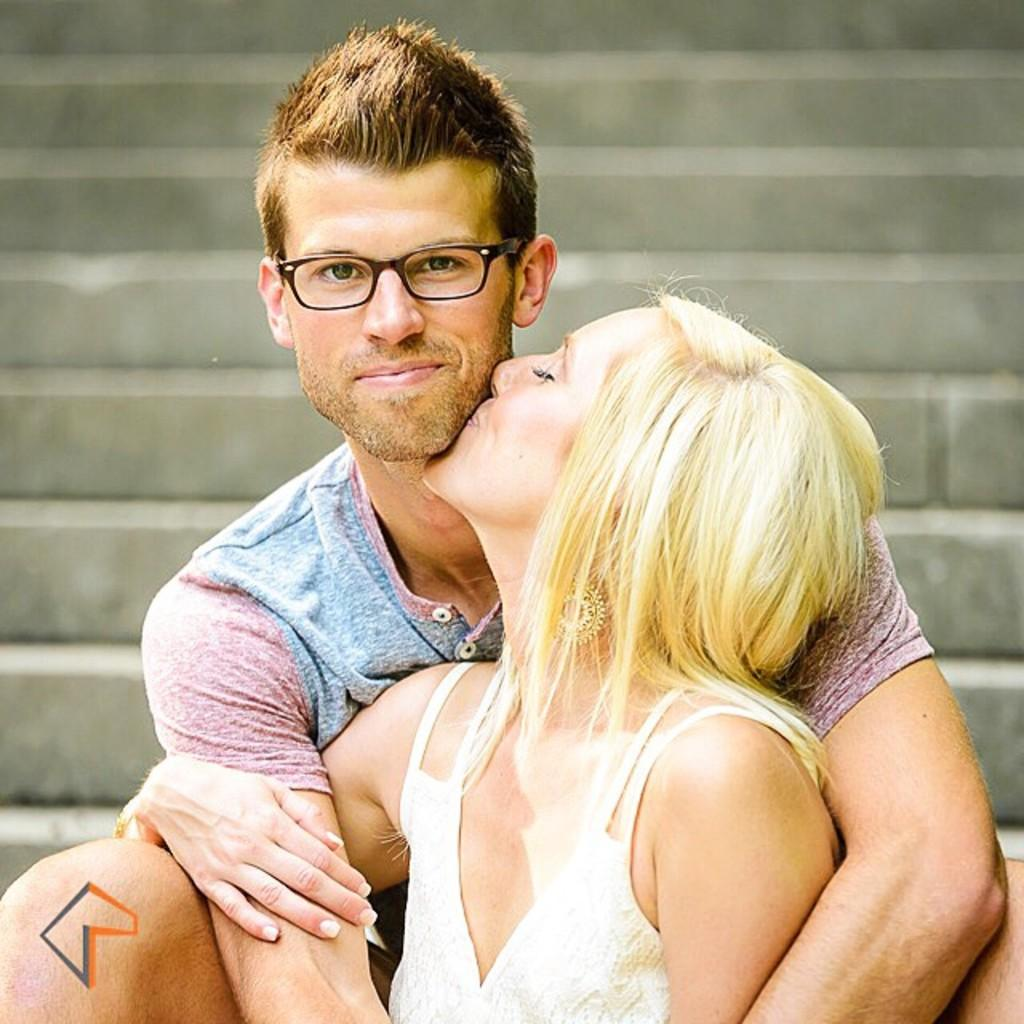Who is present in the image? There is a woman and a man in the image. What are the woman and the man doing? The woman is kissing the man, and the man is smiling. Can you describe the man's appearance? The man is wearing glasses. What can be seen in the background of the image? There are stairs visible in the background of the image. What type of steam is coming from the woman's stomach in the image? There is no steam coming from the woman's stomach in the image, as it does not depict any steam or reference to a stomach. 